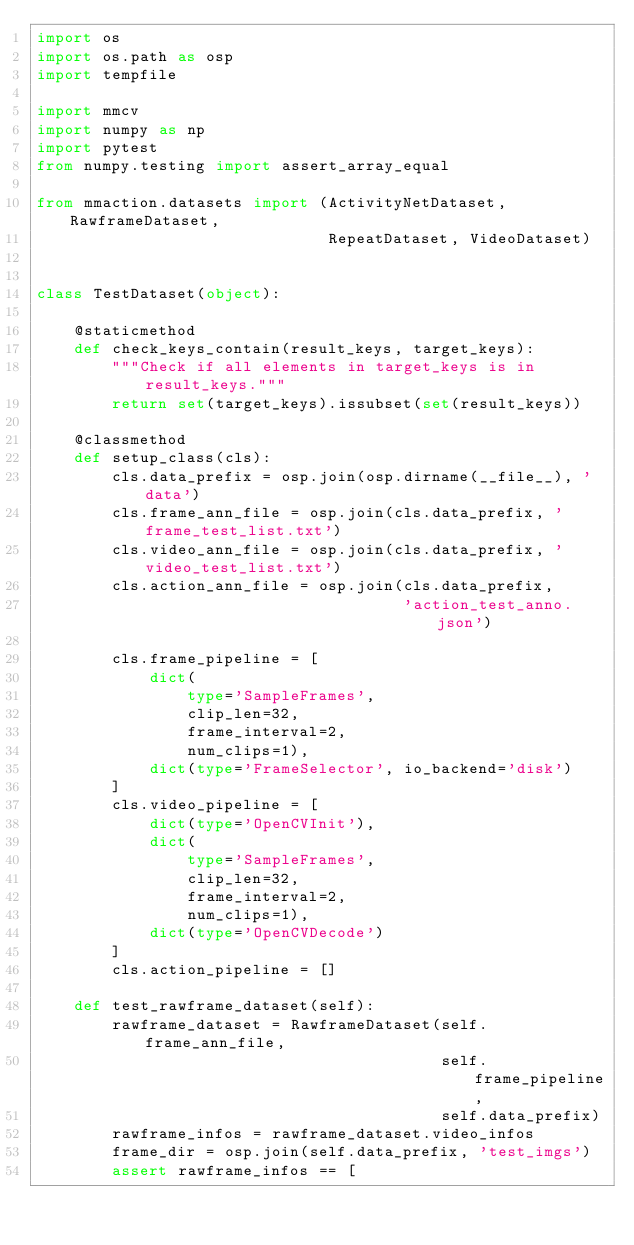Convert code to text. <code><loc_0><loc_0><loc_500><loc_500><_Python_>import os
import os.path as osp
import tempfile

import mmcv
import numpy as np
import pytest
from numpy.testing import assert_array_equal

from mmaction.datasets import (ActivityNetDataset, RawframeDataset,
                               RepeatDataset, VideoDataset)


class TestDataset(object):

    @staticmethod
    def check_keys_contain(result_keys, target_keys):
        """Check if all elements in target_keys is in result_keys."""
        return set(target_keys).issubset(set(result_keys))

    @classmethod
    def setup_class(cls):
        cls.data_prefix = osp.join(osp.dirname(__file__), 'data')
        cls.frame_ann_file = osp.join(cls.data_prefix, 'frame_test_list.txt')
        cls.video_ann_file = osp.join(cls.data_prefix, 'video_test_list.txt')
        cls.action_ann_file = osp.join(cls.data_prefix,
                                       'action_test_anno.json')

        cls.frame_pipeline = [
            dict(
                type='SampleFrames',
                clip_len=32,
                frame_interval=2,
                num_clips=1),
            dict(type='FrameSelector', io_backend='disk')
        ]
        cls.video_pipeline = [
            dict(type='OpenCVInit'),
            dict(
                type='SampleFrames',
                clip_len=32,
                frame_interval=2,
                num_clips=1),
            dict(type='OpenCVDecode')
        ]
        cls.action_pipeline = []

    def test_rawframe_dataset(self):
        rawframe_dataset = RawframeDataset(self.frame_ann_file,
                                           self.frame_pipeline,
                                           self.data_prefix)
        rawframe_infos = rawframe_dataset.video_infos
        frame_dir = osp.join(self.data_prefix, 'test_imgs')
        assert rawframe_infos == [</code> 